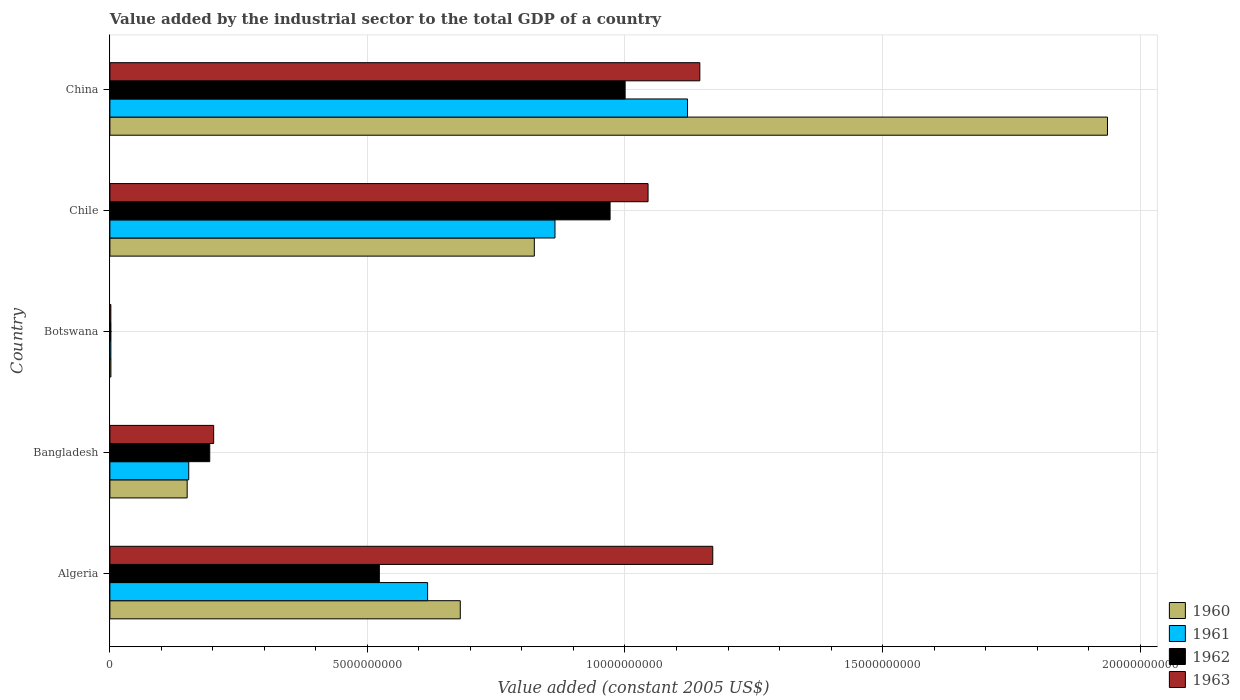How many different coloured bars are there?
Your answer should be very brief. 4. What is the value added by the industrial sector in 1962 in Bangladesh?
Offer a very short reply. 1.94e+09. Across all countries, what is the maximum value added by the industrial sector in 1963?
Offer a terse response. 1.17e+1. Across all countries, what is the minimum value added by the industrial sector in 1962?
Your response must be concise. 1.98e+07. In which country was the value added by the industrial sector in 1961 maximum?
Keep it short and to the point. China. In which country was the value added by the industrial sector in 1961 minimum?
Your answer should be very brief. Botswana. What is the total value added by the industrial sector in 1961 in the graph?
Your answer should be very brief. 2.76e+1. What is the difference between the value added by the industrial sector in 1960 in Bangladesh and that in Chile?
Offer a very short reply. -6.74e+09. What is the difference between the value added by the industrial sector in 1963 in Botswana and the value added by the industrial sector in 1960 in Chile?
Your response must be concise. -8.22e+09. What is the average value added by the industrial sector in 1960 per country?
Offer a terse response. 7.19e+09. What is the difference between the value added by the industrial sector in 1960 and value added by the industrial sector in 1962 in Algeria?
Your response must be concise. 1.57e+09. What is the ratio of the value added by the industrial sector in 1961 in Bangladesh to that in Chile?
Offer a very short reply. 0.18. Is the value added by the industrial sector in 1961 in Algeria less than that in Bangladesh?
Provide a succinct answer. No. Is the difference between the value added by the industrial sector in 1960 in Algeria and Chile greater than the difference between the value added by the industrial sector in 1962 in Algeria and Chile?
Make the answer very short. Yes. What is the difference between the highest and the second highest value added by the industrial sector in 1963?
Offer a terse response. 2.51e+08. What is the difference between the highest and the lowest value added by the industrial sector in 1963?
Give a very brief answer. 1.17e+1. In how many countries, is the value added by the industrial sector in 1963 greater than the average value added by the industrial sector in 1963 taken over all countries?
Give a very brief answer. 3. Is it the case that in every country, the sum of the value added by the industrial sector in 1963 and value added by the industrial sector in 1961 is greater than the sum of value added by the industrial sector in 1960 and value added by the industrial sector in 1962?
Offer a very short reply. No. What does the 3rd bar from the bottom in Chile represents?
Make the answer very short. 1962. Are all the bars in the graph horizontal?
Keep it short and to the point. Yes. How many countries are there in the graph?
Provide a short and direct response. 5. Does the graph contain any zero values?
Make the answer very short. No. Does the graph contain grids?
Your answer should be very brief. Yes. How many legend labels are there?
Give a very brief answer. 4. How are the legend labels stacked?
Make the answer very short. Vertical. What is the title of the graph?
Your response must be concise. Value added by the industrial sector to the total GDP of a country. What is the label or title of the X-axis?
Keep it short and to the point. Value added (constant 2005 US$). What is the label or title of the Y-axis?
Your answer should be compact. Country. What is the Value added (constant 2005 US$) of 1960 in Algeria?
Make the answer very short. 6.80e+09. What is the Value added (constant 2005 US$) in 1961 in Algeria?
Ensure brevity in your answer.  6.17e+09. What is the Value added (constant 2005 US$) of 1962 in Algeria?
Provide a short and direct response. 5.23e+09. What is the Value added (constant 2005 US$) of 1963 in Algeria?
Keep it short and to the point. 1.17e+1. What is the Value added (constant 2005 US$) of 1960 in Bangladesh?
Your answer should be compact. 1.50e+09. What is the Value added (constant 2005 US$) in 1961 in Bangladesh?
Your answer should be very brief. 1.53e+09. What is the Value added (constant 2005 US$) in 1962 in Bangladesh?
Your answer should be compact. 1.94e+09. What is the Value added (constant 2005 US$) of 1963 in Bangladesh?
Ensure brevity in your answer.  2.01e+09. What is the Value added (constant 2005 US$) of 1960 in Botswana?
Offer a terse response. 1.96e+07. What is the Value added (constant 2005 US$) of 1961 in Botswana?
Your response must be concise. 1.92e+07. What is the Value added (constant 2005 US$) of 1962 in Botswana?
Make the answer very short. 1.98e+07. What is the Value added (constant 2005 US$) of 1963 in Botswana?
Your answer should be compact. 1.83e+07. What is the Value added (constant 2005 US$) of 1960 in Chile?
Your response must be concise. 8.24e+09. What is the Value added (constant 2005 US$) in 1961 in Chile?
Provide a short and direct response. 8.64e+09. What is the Value added (constant 2005 US$) in 1962 in Chile?
Keep it short and to the point. 9.71e+09. What is the Value added (constant 2005 US$) in 1963 in Chile?
Give a very brief answer. 1.04e+1. What is the Value added (constant 2005 US$) of 1960 in China?
Provide a succinct answer. 1.94e+1. What is the Value added (constant 2005 US$) in 1961 in China?
Provide a succinct answer. 1.12e+1. What is the Value added (constant 2005 US$) of 1962 in China?
Your answer should be compact. 1.00e+1. What is the Value added (constant 2005 US$) in 1963 in China?
Provide a succinct answer. 1.15e+1. Across all countries, what is the maximum Value added (constant 2005 US$) of 1960?
Provide a short and direct response. 1.94e+1. Across all countries, what is the maximum Value added (constant 2005 US$) of 1961?
Make the answer very short. 1.12e+1. Across all countries, what is the maximum Value added (constant 2005 US$) of 1962?
Ensure brevity in your answer.  1.00e+1. Across all countries, what is the maximum Value added (constant 2005 US$) in 1963?
Keep it short and to the point. 1.17e+1. Across all countries, what is the minimum Value added (constant 2005 US$) of 1960?
Make the answer very short. 1.96e+07. Across all countries, what is the minimum Value added (constant 2005 US$) of 1961?
Offer a terse response. 1.92e+07. Across all countries, what is the minimum Value added (constant 2005 US$) of 1962?
Offer a terse response. 1.98e+07. Across all countries, what is the minimum Value added (constant 2005 US$) in 1963?
Offer a terse response. 1.83e+07. What is the total Value added (constant 2005 US$) of 1960 in the graph?
Provide a short and direct response. 3.59e+1. What is the total Value added (constant 2005 US$) of 1961 in the graph?
Make the answer very short. 2.76e+1. What is the total Value added (constant 2005 US$) in 1962 in the graph?
Offer a very short reply. 2.69e+1. What is the total Value added (constant 2005 US$) of 1963 in the graph?
Ensure brevity in your answer.  3.56e+1. What is the difference between the Value added (constant 2005 US$) of 1960 in Algeria and that in Bangladesh?
Your answer should be compact. 5.30e+09. What is the difference between the Value added (constant 2005 US$) of 1961 in Algeria and that in Bangladesh?
Ensure brevity in your answer.  4.64e+09. What is the difference between the Value added (constant 2005 US$) of 1962 in Algeria and that in Bangladesh?
Make the answer very short. 3.29e+09. What is the difference between the Value added (constant 2005 US$) of 1963 in Algeria and that in Bangladesh?
Ensure brevity in your answer.  9.69e+09. What is the difference between the Value added (constant 2005 US$) of 1960 in Algeria and that in Botswana?
Offer a very short reply. 6.78e+09. What is the difference between the Value added (constant 2005 US$) in 1961 in Algeria and that in Botswana?
Your response must be concise. 6.15e+09. What is the difference between the Value added (constant 2005 US$) of 1962 in Algeria and that in Botswana?
Ensure brevity in your answer.  5.21e+09. What is the difference between the Value added (constant 2005 US$) of 1963 in Algeria and that in Botswana?
Provide a short and direct response. 1.17e+1. What is the difference between the Value added (constant 2005 US$) of 1960 in Algeria and that in Chile?
Provide a short and direct response. -1.44e+09. What is the difference between the Value added (constant 2005 US$) of 1961 in Algeria and that in Chile?
Your answer should be very brief. -2.47e+09. What is the difference between the Value added (constant 2005 US$) of 1962 in Algeria and that in Chile?
Your answer should be compact. -4.48e+09. What is the difference between the Value added (constant 2005 US$) of 1963 in Algeria and that in Chile?
Provide a short and direct response. 1.26e+09. What is the difference between the Value added (constant 2005 US$) in 1960 in Algeria and that in China?
Give a very brief answer. -1.26e+1. What is the difference between the Value added (constant 2005 US$) of 1961 in Algeria and that in China?
Offer a terse response. -5.05e+09. What is the difference between the Value added (constant 2005 US$) of 1962 in Algeria and that in China?
Give a very brief answer. -4.77e+09. What is the difference between the Value added (constant 2005 US$) of 1963 in Algeria and that in China?
Your response must be concise. 2.51e+08. What is the difference between the Value added (constant 2005 US$) of 1960 in Bangladesh and that in Botswana?
Your answer should be very brief. 1.48e+09. What is the difference between the Value added (constant 2005 US$) in 1961 in Bangladesh and that in Botswana?
Your response must be concise. 1.51e+09. What is the difference between the Value added (constant 2005 US$) of 1962 in Bangladesh and that in Botswana?
Offer a very short reply. 1.92e+09. What is the difference between the Value added (constant 2005 US$) of 1963 in Bangladesh and that in Botswana?
Give a very brief answer. 2.00e+09. What is the difference between the Value added (constant 2005 US$) in 1960 in Bangladesh and that in Chile?
Your answer should be compact. -6.74e+09. What is the difference between the Value added (constant 2005 US$) of 1961 in Bangladesh and that in Chile?
Provide a succinct answer. -7.11e+09. What is the difference between the Value added (constant 2005 US$) of 1962 in Bangladesh and that in Chile?
Offer a terse response. -7.77e+09. What is the difference between the Value added (constant 2005 US$) in 1963 in Bangladesh and that in Chile?
Keep it short and to the point. -8.43e+09. What is the difference between the Value added (constant 2005 US$) in 1960 in Bangladesh and that in China?
Your answer should be compact. -1.79e+1. What is the difference between the Value added (constant 2005 US$) in 1961 in Bangladesh and that in China?
Offer a terse response. -9.68e+09. What is the difference between the Value added (constant 2005 US$) of 1962 in Bangladesh and that in China?
Keep it short and to the point. -8.06e+09. What is the difference between the Value added (constant 2005 US$) of 1963 in Bangladesh and that in China?
Your answer should be very brief. -9.44e+09. What is the difference between the Value added (constant 2005 US$) of 1960 in Botswana and that in Chile?
Offer a terse response. -8.22e+09. What is the difference between the Value added (constant 2005 US$) of 1961 in Botswana and that in Chile?
Ensure brevity in your answer.  -8.62e+09. What is the difference between the Value added (constant 2005 US$) of 1962 in Botswana and that in Chile?
Offer a very short reply. -9.69e+09. What is the difference between the Value added (constant 2005 US$) in 1963 in Botswana and that in Chile?
Offer a terse response. -1.04e+1. What is the difference between the Value added (constant 2005 US$) of 1960 in Botswana and that in China?
Keep it short and to the point. -1.93e+1. What is the difference between the Value added (constant 2005 US$) in 1961 in Botswana and that in China?
Offer a very short reply. -1.12e+1. What is the difference between the Value added (constant 2005 US$) of 1962 in Botswana and that in China?
Provide a short and direct response. -9.98e+09. What is the difference between the Value added (constant 2005 US$) in 1963 in Botswana and that in China?
Keep it short and to the point. -1.14e+1. What is the difference between the Value added (constant 2005 US$) in 1960 in Chile and that in China?
Make the answer very short. -1.11e+1. What is the difference between the Value added (constant 2005 US$) in 1961 in Chile and that in China?
Offer a terse response. -2.57e+09. What is the difference between the Value added (constant 2005 US$) in 1962 in Chile and that in China?
Provide a succinct answer. -2.92e+08. What is the difference between the Value added (constant 2005 US$) in 1963 in Chile and that in China?
Provide a succinct answer. -1.01e+09. What is the difference between the Value added (constant 2005 US$) in 1960 in Algeria and the Value added (constant 2005 US$) in 1961 in Bangladesh?
Ensure brevity in your answer.  5.27e+09. What is the difference between the Value added (constant 2005 US$) of 1960 in Algeria and the Value added (constant 2005 US$) of 1962 in Bangladesh?
Your answer should be compact. 4.86e+09. What is the difference between the Value added (constant 2005 US$) of 1960 in Algeria and the Value added (constant 2005 US$) of 1963 in Bangladesh?
Provide a succinct answer. 4.79e+09. What is the difference between the Value added (constant 2005 US$) in 1961 in Algeria and the Value added (constant 2005 US$) in 1962 in Bangladesh?
Ensure brevity in your answer.  4.23e+09. What is the difference between the Value added (constant 2005 US$) of 1961 in Algeria and the Value added (constant 2005 US$) of 1963 in Bangladesh?
Keep it short and to the point. 4.15e+09. What is the difference between the Value added (constant 2005 US$) of 1962 in Algeria and the Value added (constant 2005 US$) of 1963 in Bangladesh?
Ensure brevity in your answer.  3.22e+09. What is the difference between the Value added (constant 2005 US$) of 1960 in Algeria and the Value added (constant 2005 US$) of 1961 in Botswana?
Your answer should be compact. 6.78e+09. What is the difference between the Value added (constant 2005 US$) in 1960 in Algeria and the Value added (constant 2005 US$) in 1962 in Botswana?
Make the answer very short. 6.78e+09. What is the difference between the Value added (constant 2005 US$) of 1960 in Algeria and the Value added (constant 2005 US$) of 1963 in Botswana?
Your answer should be compact. 6.78e+09. What is the difference between the Value added (constant 2005 US$) in 1961 in Algeria and the Value added (constant 2005 US$) in 1962 in Botswana?
Your answer should be very brief. 6.15e+09. What is the difference between the Value added (constant 2005 US$) of 1961 in Algeria and the Value added (constant 2005 US$) of 1963 in Botswana?
Your answer should be compact. 6.15e+09. What is the difference between the Value added (constant 2005 US$) of 1962 in Algeria and the Value added (constant 2005 US$) of 1963 in Botswana?
Your response must be concise. 5.21e+09. What is the difference between the Value added (constant 2005 US$) of 1960 in Algeria and the Value added (constant 2005 US$) of 1961 in Chile?
Provide a short and direct response. -1.84e+09. What is the difference between the Value added (constant 2005 US$) of 1960 in Algeria and the Value added (constant 2005 US$) of 1962 in Chile?
Your answer should be compact. -2.91e+09. What is the difference between the Value added (constant 2005 US$) in 1960 in Algeria and the Value added (constant 2005 US$) in 1963 in Chile?
Offer a terse response. -3.65e+09. What is the difference between the Value added (constant 2005 US$) in 1961 in Algeria and the Value added (constant 2005 US$) in 1962 in Chile?
Your answer should be very brief. -3.54e+09. What is the difference between the Value added (constant 2005 US$) of 1961 in Algeria and the Value added (constant 2005 US$) of 1963 in Chile?
Your answer should be compact. -4.28e+09. What is the difference between the Value added (constant 2005 US$) of 1962 in Algeria and the Value added (constant 2005 US$) of 1963 in Chile?
Offer a very short reply. -5.22e+09. What is the difference between the Value added (constant 2005 US$) in 1960 in Algeria and the Value added (constant 2005 US$) in 1961 in China?
Your answer should be very brief. -4.41e+09. What is the difference between the Value added (constant 2005 US$) in 1960 in Algeria and the Value added (constant 2005 US$) in 1962 in China?
Provide a short and direct response. -3.20e+09. What is the difference between the Value added (constant 2005 US$) of 1960 in Algeria and the Value added (constant 2005 US$) of 1963 in China?
Your answer should be compact. -4.65e+09. What is the difference between the Value added (constant 2005 US$) of 1961 in Algeria and the Value added (constant 2005 US$) of 1962 in China?
Ensure brevity in your answer.  -3.83e+09. What is the difference between the Value added (constant 2005 US$) in 1961 in Algeria and the Value added (constant 2005 US$) in 1963 in China?
Your answer should be compact. -5.28e+09. What is the difference between the Value added (constant 2005 US$) in 1962 in Algeria and the Value added (constant 2005 US$) in 1963 in China?
Make the answer very short. -6.22e+09. What is the difference between the Value added (constant 2005 US$) of 1960 in Bangladesh and the Value added (constant 2005 US$) of 1961 in Botswana?
Your answer should be compact. 1.48e+09. What is the difference between the Value added (constant 2005 US$) of 1960 in Bangladesh and the Value added (constant 2005 US$) of 1962 in Botswana?
Your answer should be very brief. 1.48e+09. What is the difference between the Value added (constant 2005 US$) of 1960 in Bangladesh and the Value added (constant 2005 US$) of 1963 in Botswana?
Provide a short and direct response. 1.48e+09. What is the difference between the Value added (constant 2005 US$) of 1961 in Bangladesh and the Value added (constant 2005 US$) of 1962 in Botswana?
Keep it short and to the point. 1.51e+09. What is the difference between the Value added (constant 2005 US$) of 1961 in Bangladesh and the Value added (constant 2005 US$) of 1963 in Botswana?
Keep it short and to the point. 1.51e+09. What is the difference between the Value added (constant 2005 US$) of 1962 in Bangladesh and the Value added (constant 2005 US$) of 1963 in Botswana?
Keep it short and to the point. 1.92e+09. What is the difference between the Value added (constant 2005 US$) in 1960 in Bangladesh and the Value added (constant 2005 US$) in 1961 in Chile?
Provide a succinct answer. -7.14e+09. What is the difference between the Value added (constant 2005 US$) in 1960 in Bangladesh and the Value added (constant 2005 US$) in 1962 in Chile?
Offer a terse response. -8.21e+09. What is the difference between the Value added (constant 2005 US$) in 1960 in Bangladesh and the Value added (constant 2005 US$) in 1963 in Chile?
Offer a very short reply. -8.95e+09. What is the difference between the Value added (constant 2005 US$) of 1961 in Bangladesh and the Value added (constant 2005 US$) of 1962 in Chile?
Offer a very short reply. -8.18e+09. What is the difference between the Value added (constant 2005 US$) in 1961 in Bangladesh and the Value added (constant 2005 US$) in 1963 in Chile?
Provide a short and direct response. -8.92e+09. What is the difference between the Value added (constant 2005 US$) of 1962 in Bangladesh and the Value added (constant 2005 US$) of 1963 in Chile?
Keep it short and to the point. -8.51e+09. What is the difference between the Value added (constant 2005 US$) in 1960 in Bangladesh and the Value added (constant 2005 US$) in 1961 in China?
Your answer should be compact. -9.71e+09. What is the difference between the Value added (constant 2005 US$) in 1960 in Bangladesh and the Value added (constant 2005 US$) in 1962 in China?
Your response must be concise. -8.50e+09. What is the difference between the Value added (constant 2005 US$) in 1960 in Bangladesh and the Value added (constant 2005 US$) in 1963 in China?
Make the answer very short. -9.95e+09. What is the difference between the Value added (constant 2005 US$) in 1961 in Bangladesh and the Value added (constant 2005 US$) in 1962 in China?
Your answer should be very brief. -8.47e+09. What is the difference between the Value added (constant 2005 US$) of 1961 in Bangladesh and the Value added (constant 2005 US$) of 1963 in China?
Keep it short and to the point. -9.92e+09. What is the difference between the Value added (constant 2005 US$) in 1962 in Bangladesh and the Value added (constant 2005 US$) in 1963 in China?
Make the answer very short. -9.51e+09. What is the difference between the Value added (constant 2005 US$) of 1960 in Botswana and the Value added (constant 2005 US$) of 1961 in Chile?
Offer a very short reply. -8.62e+09. What is the difference between the Value added (constant 2005 US$) of 1960 in Botswana and the Value added (constant 2005 US$) of 1962 in Chile?
Ensure brevity in your answer.  -9.69e+09. What is the difference between the Value added (constant 2005 US$) in 1960 in Botswana and the Value added (constant 2005 US$) in 1963 in Chile?
Provide a short and direct response. -1.04e+1. What is the difference between the Value added (constant 2005 US$) in 1961 in Botswana and the Value added (constant 2005 US$) in 1962 in Chile?
Make the answer very short. -9.69e+09. What is the difference between the Value added (constant 2005 US$) of 1961 in Botswana and the Value added (constant 2005 US$) of 1963 in Chile?
Give a very brief answer. -1.04e+1. What is the difference between the Value added (constant 2005 US$) of 1962 in Botswana and the Value added (constant 2005 US$) of 1963 in Chile?
Make the answer very short. -1.04e+1. What is the difference between the Value added (constant 2005 US$) in 1960 in Botswana and the Value added (constant 2005 US$) in 1961 in China?
Keep it short and to the point. -1.12e+1. What is the difference between the Value added (constant 2005 US$) in 1960 in Botswana and the Value added (constant 2005 US$) in 1962 in China?
Ensure brevity in your answer.  -9.98e+09. What is the difference between the Value added (constant 2005 US$) of 1960 in Botswana and the Value added (constant 2005 US$) of 1963 in China?
Give a very brief answer. -1.14e+1. What is the difference between the Value added (constant 2005 US$) of 1961 in Botswana and the Value added (constant 2005 US$) of 1962 in China?
Ensure brevity in your answer.  -9.98e+09. What is the difference between the Value added (constant 2005 US$) of 1961 in Botswana and the Value added (constant 2005 US$) of 1963 in China?
Make the answer very short. -1.14e+1. What is the difference between the Value added (constant 2005 US$) in 1962 in Botswana and the Value added (constant 2005 US$) in 1963 in China?
Provide a short and direct response. -1.14e+1. What is the difference between the Value added (constant 2005 US$) of 1960 in Chile and the Value added (constant 2005 US$) of 1961 in China?
Your answer should be very brief. -2.97e+09. What is the difference between the Value added (constant 2005 US$) in 1960 in Chile and the Value added (constant 2005 US$) in 1962 in China?
Offer a very short reply. -1.76e+09. What is the difference between the Value added (constant 2005 US$) of 1960 in Chile and the Value added (constant 2005 US$) of 1963 in China?
Give a very brief answer. -3.21e+09. What is the difference between the Value added (constant 2005 US$) of 1961 in Chile and the Value added (constant 2005 US$) of 1962 in China?
Make the answer very short. -1.36e+09. What is the difference between the Value added (constant 2005 US$) of 1961 in Chile and the Value added (constant 2005 US$) of 1963 in China?
Give a very brief answer. -2.81e+09. What is the difference between the Value added (constant 2005 US$) of 1962 in Chile and the Value added (constant 2005 US$) of 1963 in China?
Ensure brevity in your answer.  -1.74e+09. What is the average Value added (constant 2005 US$) in 1960 per country?
Offer a very short reply. 7.19e+09. What is the average Value added (constant 2005 US$) of 1961 per country?
Provide a succinct answer. 5.51e+09. What is the average Value added (constant 2005 US$) of 1962 per country?
Give a very brief answer. 5.38e+09. What is the average Value added (constant 2005 US$) in 1963 per country?
Offer a terse response. 7.13e+09. What is the difference between the Value added (constant 2005 US$) in 1960 and Value added (constant 2005 US$) in 1961 in Algeria?
Your answer should be very brief. 6.34e+08. What is the difference between the Value added (constant 2005 US$) of 1960 and Value added (constant 2005 US$) of 1962 in Algeria?
Provide a short and direct response. 1.57e+09. What is the difference between the Value added (constant 2005 US$) in 1960 and Value added (constant 2005 US$) in 1963 in Algeria?
Your answer should be compact. -4.90e+09. What is the difference between the Value added (constant 2005 US$) of 1961 and Value added (constant 2005 US$) of 1962 in Algeria?
Make the answer very short. 9.37e+08. What is the difference between the Value added (constant 2005 US$) of 1961 and Value added (constant 2005 US$) of 1963 in Algeria?
Your answer should be very brief. -5.54e+09. What is the difference between the Value added (constant 2005 US$) in 1962 and Value added (constant 2005 US$) in 1963 in Algeria?
Your response must be concise. -6.47e+09. What is the difference between the Value added (constant 2005 US$) of 1960 and Value added (constant 2005 US$) of 1961 in Bangladesh?
Ensure brevity in your answer.  -3.05e+07. What is the difference between the Value added (constant 2005 US$) in 1960 and Value added (constant 2005 US$) in 1962 in Bangladesh?
Offer a terse response. -4.38e+08. What is the difference between the Value added (constant 2005 US$) of 1960 and Value added (constant 2005 US$) of 1963 in Bangladesh?
Your answer should be very brief. -5.14e+08. What is the difference between the Value added (constant 2005 US$) of 1961 and Value added (constant 2005 US$) of 1962 in Bangladesh?
Keep it short and to the point. -4.08e+08. What is the difference between the Value added (constant 2005 US$) in 1961 and Value added (constant 2005 US$) in 1963 in Bangladesh?
Keep it short and to the point. -4.84e+08. What is the difference between the Value added (constant 2005 US$) of 1962 and Value added (constant 2005 US$) of 1963 in Bangladesh?
Your answer should be compact. -7.60e+07. What is the difference between the Value added (constant 2005 US$) of 1960 and Value added (constant 2005 US$) of 1961 in Botswana?
Provide a succinct answer. 4.24e+05. What is the difference between the Value added (constant 2005 US$) of 1960 and Value added (constant 2005 US$) of 1962 in Botswana?
Your answer should be very brief. -2.12e+05. What is the difference between the Value added (constant 2005 US$) in 1960 and Value added (constant 2005 US$) in 1963 in Botswana?
Provide a short and direct response. 1.27e+06. What is the difference between the Value added (constant 2005 US$) of 1961 and Value added (constant 2005 US$) of 1962 in Botswana?
Offer a terse response. -6.36e+05. What is the difference between the Value added (constant 2005 US$) of 1961 and Value added (constant 2005 US$) of 1963 in Botswana?
Your answer should be compact. 8.48e+05. What is the difference between the Value added (constant 2005 US$) of 1962 and Value added (constant 2005 US$) of 1963 in Botswana?
Give a very brief answer. 1.48e+06. What is the difference between the Value added (constant 2005 US$) of 1960 and Value added (constant 2005 US$) of 1961 in Chile?
Offer a very short reply. -4.01e+08. What is the difference between the Value added (constant 2005 US$) of 1960 and Value added (constant 2005 US$) of 1962 in Chile?
Ensure brevity in your answer.  -1.47e+09. What is the difference between the Value added (constant 2005 US$) of 1960 and Value added (constant 2005 US$) of 1963 in Chile?
Your answer should be compact. -2.21e+09. What is the difference between the Value added (constant 2005 US$) of 1961 and Value added (constant 2005 US$) of 1962 in Chile?
Provide a succinct answer. -1.07e+09. What is the difference between the Value added (constant 2005 US$) of 1961 and Value added (constant 2005 US$) of 1963 in Chile?
Make the answer very short. -1.81e+09. What is the difference between the Value added (constant 2005 US$) of 1962 and Value added (constant 2005 US$) of 1963 in Chile?
Give a very brief answer. -7.37e+08. What is the difference between the Value added (constant 2005 US$) of 1960 and Value added (constant 2005 US$) of 1961 in China?
Your answer should be compact. 8.15e+09. What is the difference between the Value added (constant 2005 US$) in 1960 and Value added (constant 2005 US$) in 1962 in China?
Offer a very short reply. 9.36e+09. What is the difference between the Value added (constant 2005 US$) in 1960 and Value added (constant 2005 US$) in 1963 in China?
Ensure brevity in your answer.  7.91e+09. What is the difference between the Value added (constant 2005 US$) of 1961 and Value added (constant 2005 US$) of 1962 in China?
Offer a very short reply. 1.21e+09. What is the difference between the Value added (constant 2005 US$) of 1961 and Value added (constant 2005 US$) of 1963 in China?
Your answer should be compact. -2.39e+08. What is the difference between the Value added (constant 2005 US$) of 1962 and Value added (constant 2005 US$) of 1963 in China?
Ensure brevity in your answer.  -1.45e+09. What is the ratio of the Value added (constant 2005 US$) of 1960 in Algeria to that in Bangladesh?
Ensure brevity in your answer.  4.53. What is the ratio of the Value added (constant 2005 US$) of 1961 in Algeria to that in Bangladesh?
Keep it short and to the point. 4.03. What is the ratio of the Value added (constant 2005 US$) of 1962 in Algeria to that in Bangladesh?
Your answer should be compact. 2.7. What is the ratio of the Value added (constant 2005 US$) of 1963 in Algeria to that in Bangladesh?
Keep it short and to the point. 5.81. What is the ratio of the Value added (constant 2005 US$) in 1960 in Algeria to that in Botswana?
Keep it short and to the point. 346.79. What is the ratio of the Value added (constant 2005 US$) in 1961 in Algeria to that in Botswana?
Offer a terse response. 321.41. What is the ratio of the Value added (constant 2005 US$) in 1962 in Algeria to that in Botswana?
Your answer should be very brief. 263.85. What is the ratio of the Value added (constant 2005 US$) in 1963 in Algeria to that in Botswana?
Provide a short and direct response. 638.08. What is the ratio of the Value added (constant 2005 US$) of 1960 in Algeria to that in Chile?
Offer a terse response. 0.83. What is the ratio of the Value added (constant 2005 US$) in 1961 in Algeria to that in Chile?
Your answer should be compact. 0.71. What is the ratio of the Value added (constant 2005 US$) of 1962 in Algeria to that in Chile?
Ensure brevity in your answer.  0.54. What is the ratio of the Value added (constant 2005 US$) in 1963 in Algeria to that in Chile?
Keep it short and to the point. 1.12. What is the ratio of the Value added (constant 2005 US$) in 1960 in Algeria to that in China?
Ensure brevity in your answer.  0.35. What is the ratio of the Value added (constant 2005 US$) in 1961 in Algeria to that in China?
Provide a short and direct response. 0.55. What is the ratio of the Value added (constant 2005 US$) in 1962 in Algeria to that in China?
Your response must be concise. 0.52. What is the ratio of the Value added (constant 2005 US$) in 1963 in Algeria to that in China?
Your response must be concise. 1.02. What is the ratio of the Value added (constant 2005 US$) in 1960 in Bangladesh to that in Botswana?
Ensure brevity in your answer.  76.48. What is the ratio of the Value added (constant 2005 US$) of 1961 in Bangladesh to that in Botswana?
Your answer should be compact. 79.76. What is the ratio of the Value added (constant 2005 US$) of 1962 in Bangladesh to that in Botswana?
Give a very brief answer. 97.78. What is the ratio of the Value added (constant 2005 US$) in 1963 in Bangladesh to that in Botswana?
Your response must be concise. 109.83. What is the ratio of the Value added (constant 2005 US$) in 1960 in Bangladesh to that in Chile?
Make the answer very short. 0.18. What is the ratio of the Value added (constant 2005 US$) of 1961 in Bangladesh to that in Chile?
Your response must be concise. 0.18. What is the ratio of the Value added (constant 2005 US$) of 1962 in Bangladesh to that in Chile?
Provide a short and direct response. 0.2. What is the ratio of the Value added (constant 2005 US$) of 1963 in Bangladesh to that in Chile?
Give a very brief answer. 0.19. What is the ratio of the Value added (constant 2005 US$) of 1960 in Bangladesh to that in China?
Your response must be concise. 0.08. What is the ratio of the Value added (constant 2005 US$) in 1961 in Bangladesh to that in China?
Give a very brief answer. 0.14. What is the ratio of the Value added (constant 2005 US$) of 1962 in Bangladesh to that in China?
Your response must be concise. 0.19. What is the ratio of the Value added (constant 2005 US$) in 1963 in Bangladesh to that in China?
Make the answer very short. 0.18. What is the ratio of the Value added (constant 2005 US$) of 1960 in Botswana to that in Chile?
Your answer should be compact. 0. What is the ratio of the Value added (constant 2005 US$) in 1961 in Botswana to that in Chile?
Your response must be concise. 0. What is the ratio of the Value added (constant 2005 US$) of 1962 in Botswana to that in Chile?
Make the answer very short. 0. What is the ratio of the Value added (constant 2005 US$) in 1963 in Botswana to that in Chile?
Your response must be concise. 0. What is the ratio of the Value added (constant 2005 US$) of 1960 in Botswana to that in China?
Provide a succinct answer. 0. What is the ratio of the Value added (constant 2005 US$) of 1961 in Botswana to that in China?
Your answer should be compact. 0. What is the ratio of the Value added (constant 2005 US$) in 1962 in Botswana to that in China?
Your answer should be compact. 0. What is the ratio of the Value added (constant 2005 US$) in 1963 in Botswana to that in China?
Ensure brevity in your answer.  0. What is the ratio of the Value added (constant 2005 US$) in 1960 in Chile to that in China?
Your response must be concise. 0.43. What is the ratio of the Value added (constant 2005 US$) of 1961 in Chile to that in China?
Ensure brevity in your answer.  0.77. What is the ratio of the Value added (constant 2005 US$) of 1962 in Chile to that in China?
Your response must be concise. 0.97. What is the ratio of the Value added (constant 2005 US$) in 1963 in Chile to that in China?
Provide a short and direct response. 0.91. What is the difference between the highest and the second highest Value added (constant 2005 US$) of 1960?
Provide a succinct answer. 1.11e+1. What is the difference between the highest and the second highest Value added (constant 2005 US$) of 1961?
Your response must be concise. 2.57e+09. What is the difference between the highest and the second highest Value added (constant 2005 US$) in 1962?
Your answer should be compact. 2.92e+08. What is the difference between the highest and the second highest Value added (constant 2005 US$) of 1963?
Your response must be concise. 2.51e+08. What is the difference between the highest and the lowest Value added (constant 2005 US$) in 1960?
Keep it short and to the point. 1.93e+1. What is the difference between the highest and the lowest Value added (constant 2005 US$) of 1961?
Give a very brief answer. 1.12e+1. What is the difference between the highest and the lowest Value added (constant 2005 US$) in 1962?
Give a very brief answer. 9.98e+09. What is the difference between the highest and the lowest Value added (constant 2005 US$) in 1963?
Keep it short and to the point. 1.17e+1. 